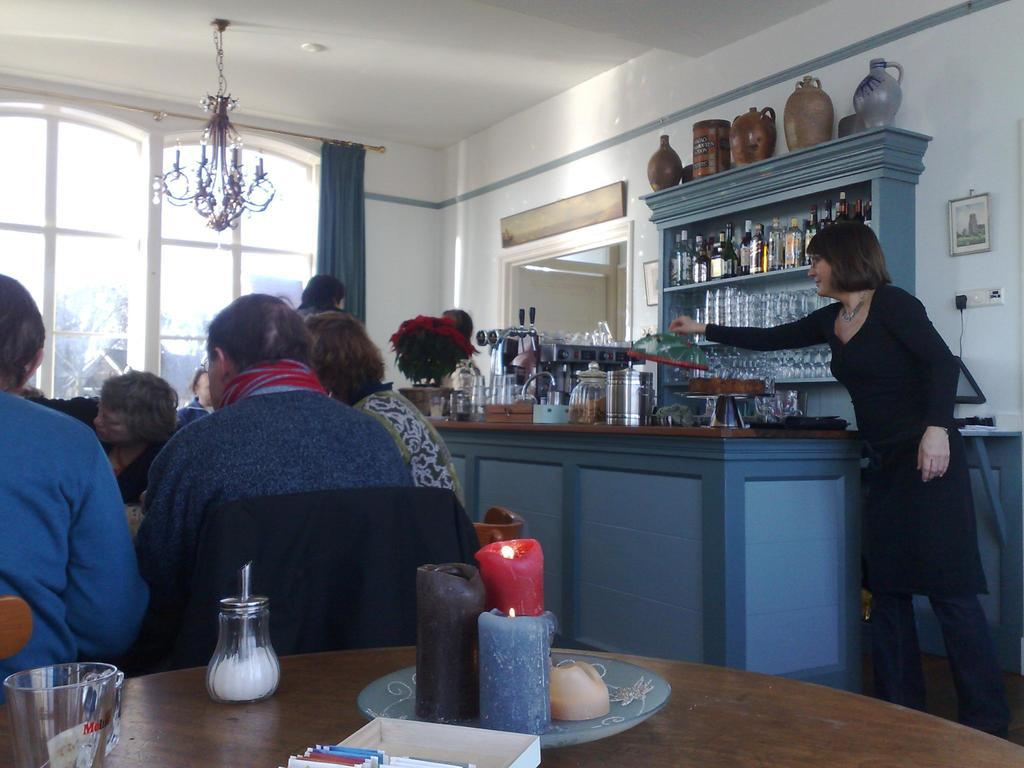What are the people in the image doing? People are sitting in chairs at tables in the image. Where is this scene taking place? The setting is a restaurant. What is a prominent feature in the restaurant? There is a bar counter in the restaurant. Can you describe the woman's position in the image? A woman is standing beside the bar counter. What type of hole can be seen in the image? There is no hole present in the image. What belief system do the people in the image follow? The image does not provide any information about the people's beliefs or belief systems. 